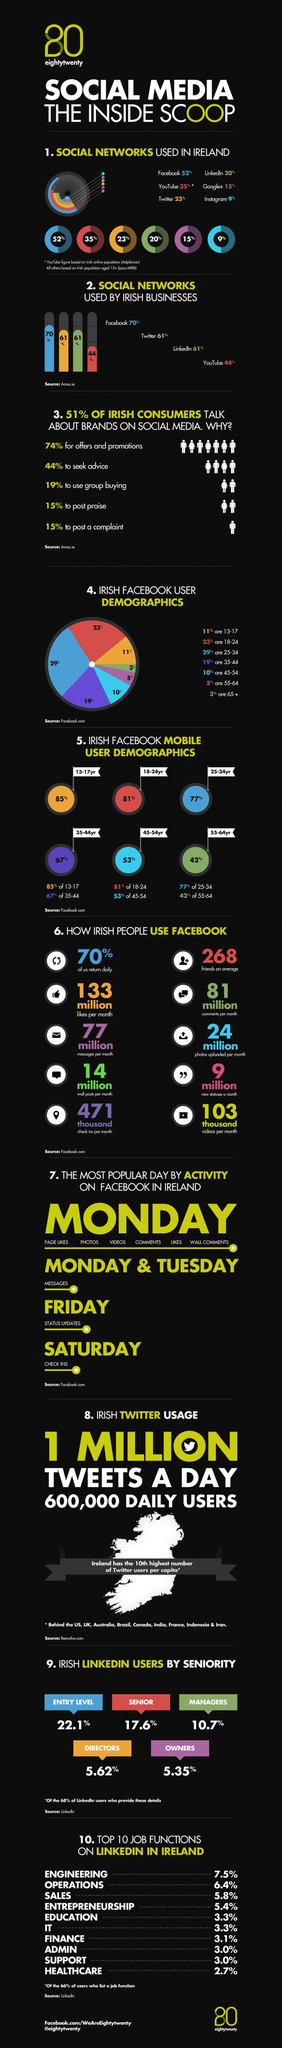Draw attention to some important aspects in this diagram. It is estimated that approximately 30% of people post praise or complaints on social media. According to data, approximately 16.32% of LinkedIn users are managers and directors. According to recent data, only 3% of senior citizens use Facebook. Facebook is the most preferred social network by businesses. The highest percentage of consumers tend to discuss offers and promotions on social media platforms. 